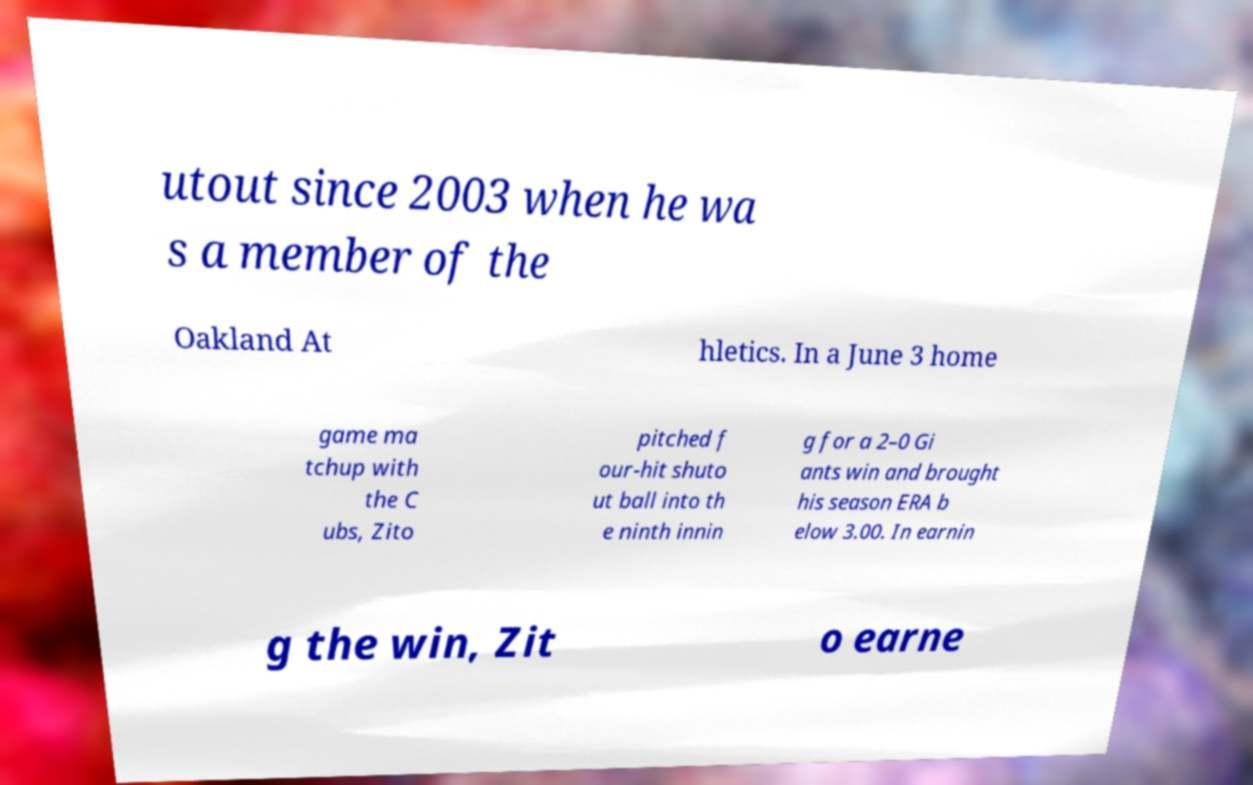Could you assist in decoding the text presented in this image and type it out clearly? utout since 2003 when he wa s a member of the Oakland At hletics. In a June 3 home game ma tchup with the C ubs, Zito pitched f our-hit shuto ut ball into th e ninth innin g for a 2–0 Gi ants win and brought his season ERA b elow 3.00. In earnin g the win, Zit o earne 